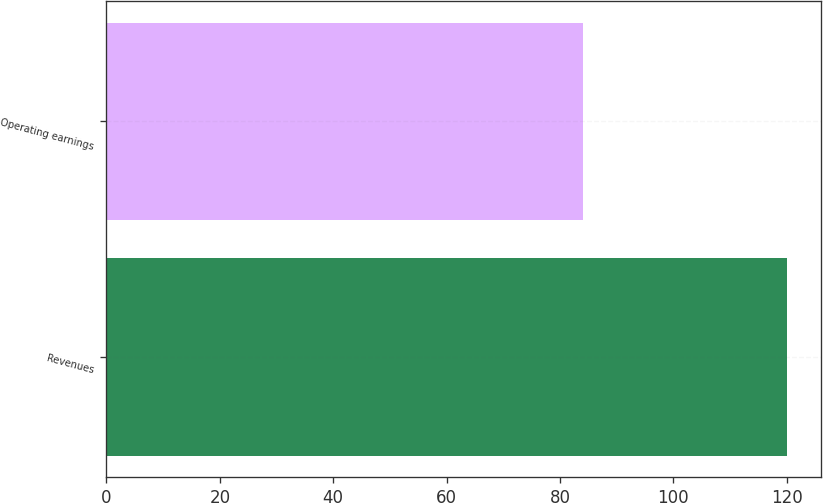Convert chart to OTSL. <chart><loc_0><loc_0><loc_500><loc_500><bar_chart><fcel>Revenues<fcel>Operating earnings<nl><fcel>120<fcel>84<nl></chart> 